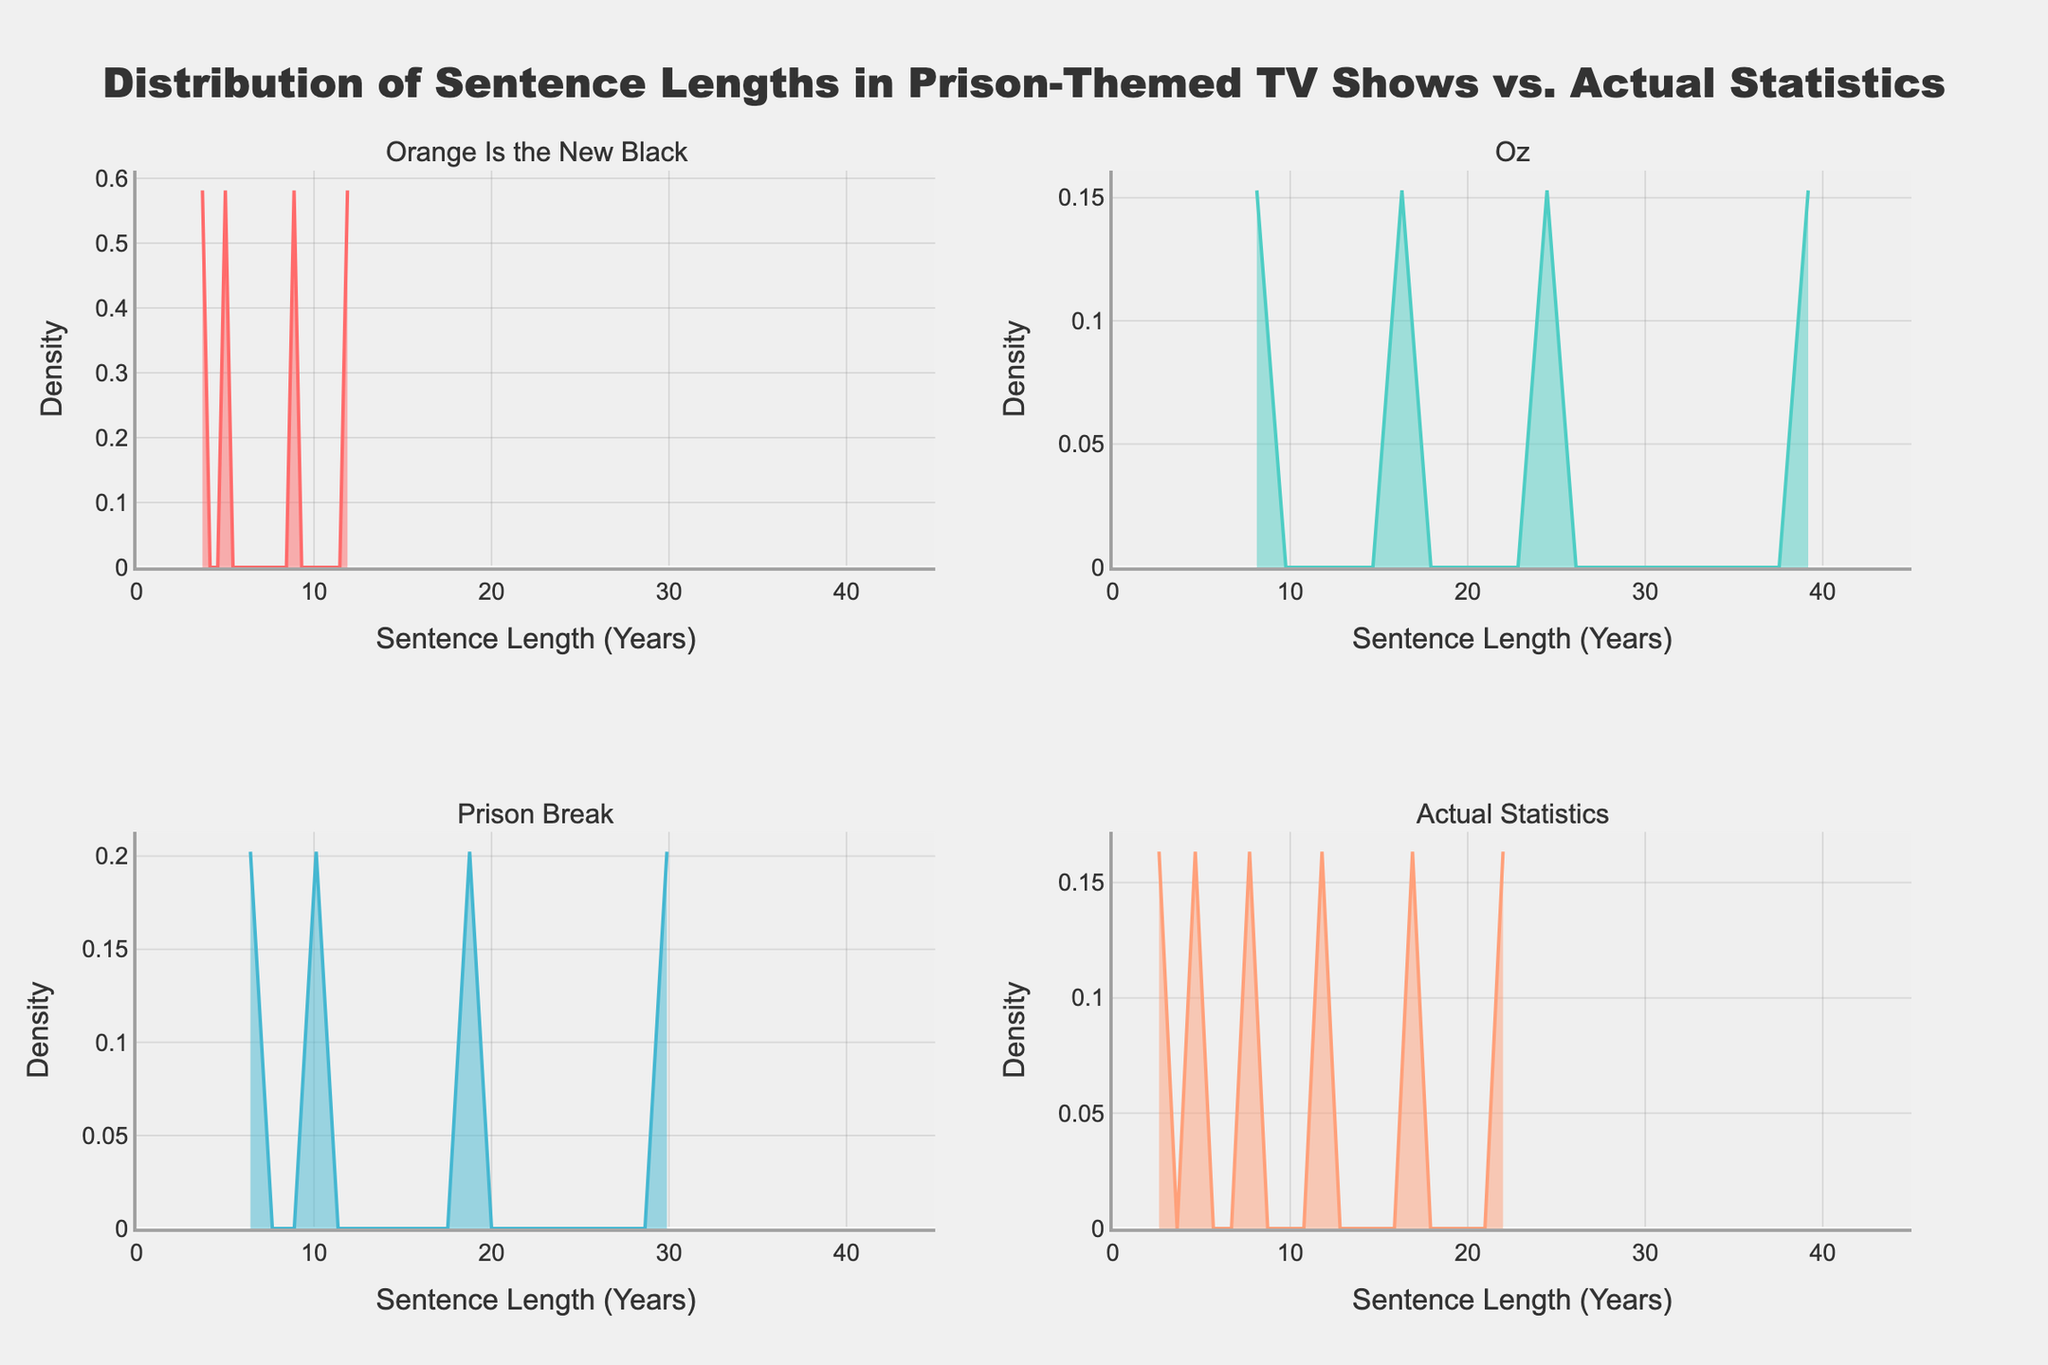What is the title of the plot? The title is visible at the top center of the figure in bold text. It reads "Distribution of Sentence Lengths in Prison-Themed TV Shows vs. Actual Statistics."
Answer: Distribution of Sentence Lengths in Prison-Themed TV Shows vs. Actual Statistics Which TV show has the longest sentence length depicted in the plot? In the subplot titled "Oz," there is a peak extending to 40 years, which is the longest sentence length depicted among the shows.
Answer: Oz What is the range of the x-axis across all subplots? The x-axis range is consistent across all subplots, ranging from 0 to 45 years. This is seen at the bottom of each subplot.
Answer: 0 to 45 years Which TV show has the widest spread in sentence lengths? The subplot for "Oz" shows a wide spread with sentence lengths ranging from below 10 years to 40 years, suggesting it has the widest spread among the TV shows.
Answer: Oz In the "Actual Statistics" subplot, what is the highest density value shown? The highest density in the "Actual Statistics" subplot peaks just below 0.1 on the y-axis.
Answer: Just below 0.1 How do the sentence lengths portrayed in "Prison Break" compare to the actual statistics? In the "Prison Break" subplot, there are higher densities for longer sentences (peaking around 30 years), whereas in "Actual Statistics," densities for sentence lengths appear to diminish after about 20 years, indicating that "Prison Break" portrays longer sentences than are statistically common.
Answer: Portrays longer sentences than actual statistics Which TV show demonstrates the closest density distribution to the "Actual Statistics"? "Orange Is the New Black" and "Actual Statistics" both show peaks around the 5-10 year mark, suggesting "Orange Is the New Black" has a density distribution closest to the real data.
Answer: Orange Is the New Black What is the sentence length where the two highest peaks occur in the "Prison Break" subplot? There is a prominent peak around 10 years and another around 30 years in the "Prison Break" subplot.
Answer: 10 years and 30 years Comparing "Oz" and "Prison Break," which show has a higher density for sentences around 15 years? In the "Oz" subplot, the density around 15 years is higher than in the "Prison Break" subplot, where the density is relatively lower for that range.
Answer: Oz What color represents the "Actual Statistics" subplot in the figure? The "Actual Statistics" subplot is represented by the color salmon, which is distinct among the four subplots.
Answer: Salmon 